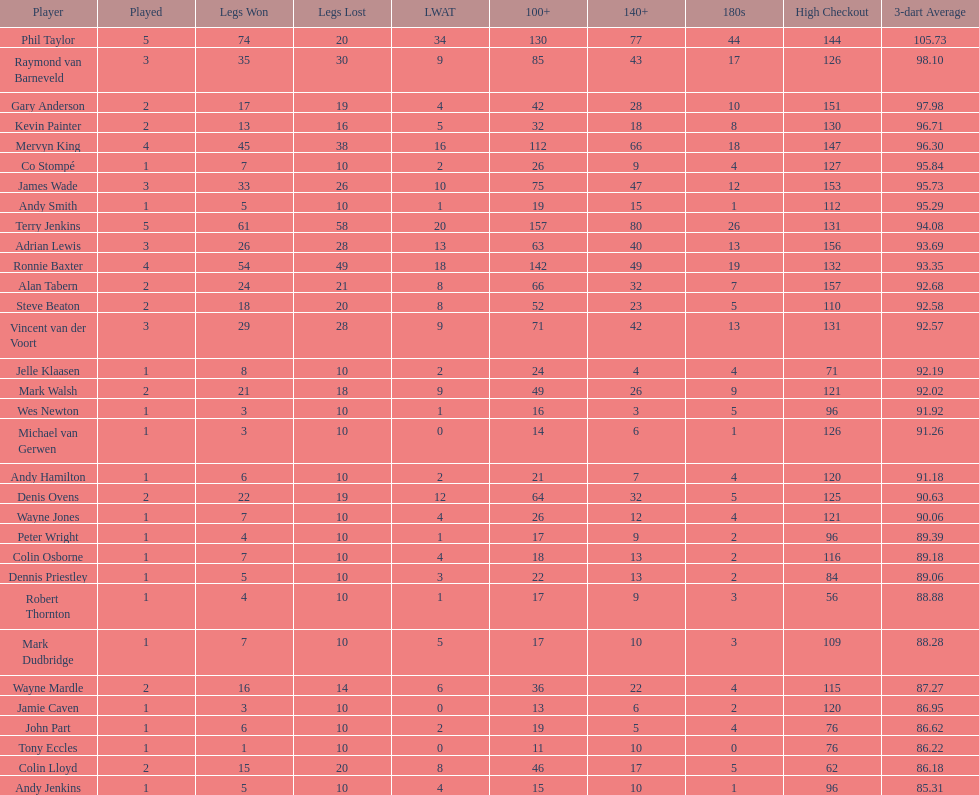Was andy smith or kevin painter's 3-dart average 96.71? Kevin Painter. 